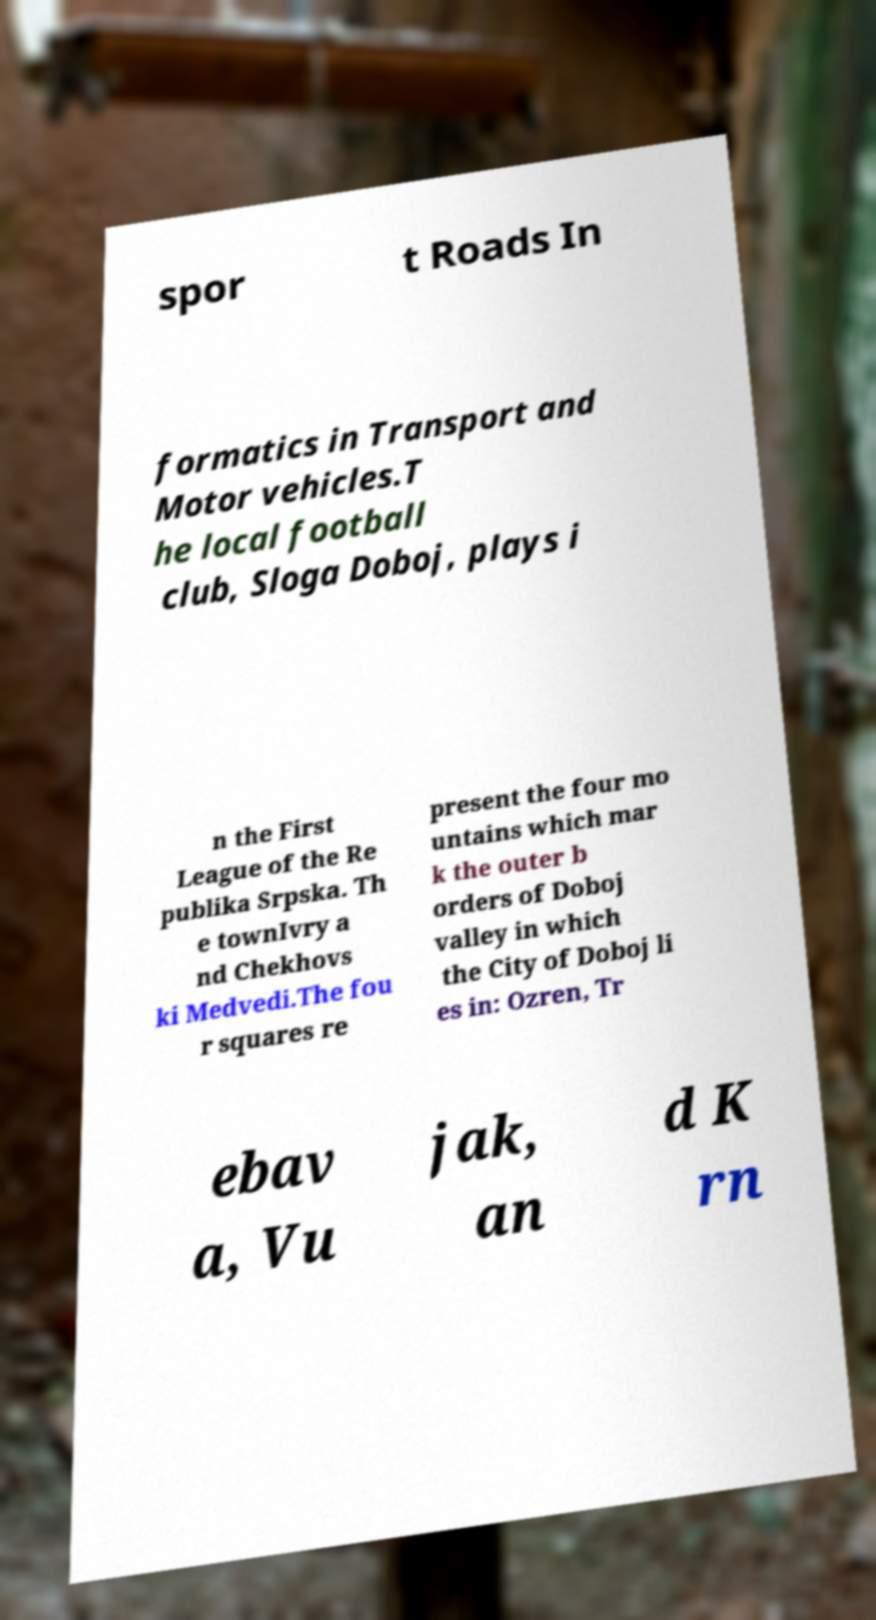What messages or text are displayed in this image? I need them in a readable, typed format. spor t Roads In formatics in Transport and Motor vehicles.T he local football club, Sloga Doboj, plays i n the First League of the Re publika Srpska. Th e townIvry a nd Chekhovs ki Medvedi.The fou r squares re present the four mo untains which mar k the outer b orders of Doboj valley in which the City of Doboj li es in: Ozren, Tr ebav a, Vu jak, an d K rn 